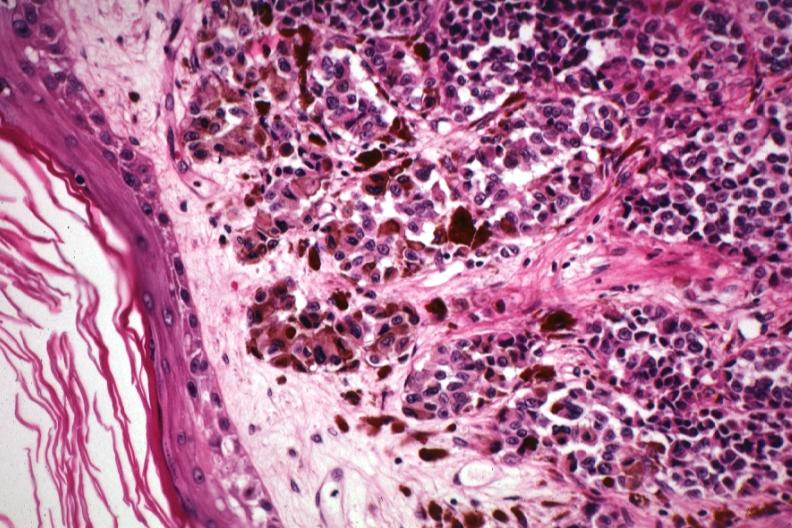does hilar cell tumor show excellent showing lesion just beneath epidermis with pigmented and non-pigmented cells?
Answer the question using a single word or phrase. No 